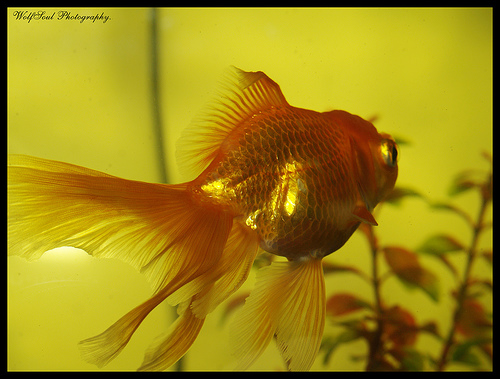<image>
Can you confirm if the goldfish is under the fishtank plant? No. The goldfish is not positioned under the fishtank plant. The vertical relationship between these objects is different. Is the fish in the plant? No. The fish is not contained within the plant. These objects have a different spatial relationship. 